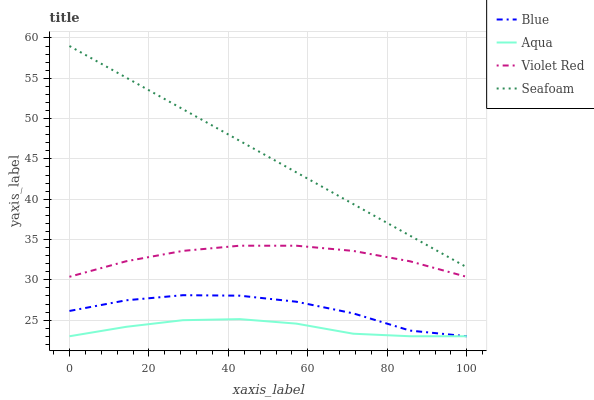Does Violet Red have the minimum area under the curve?
Answer yes or no. No. Does Violet Red have the maximum area under the curve?
Answer yes or no. No. Is Violet Red the smoothest?
Answer yes or no. No. Is Violet Red the roughest?
Answer yes or no. No. Does Violet Red have the lowest value?
Answer yes or no. No. Does Violet Red have the highest value?
Answer yes or no. No. Is Violet Red less than Seafoam?
Answer yes or no. Yes. Is Violet Red greater than Aqua?
Answer yes or no. Yes. Does Violet Red intersect Seafoam?
Answer yes or no. No. 